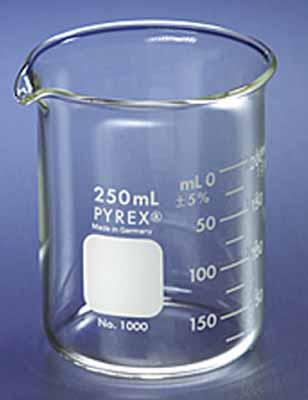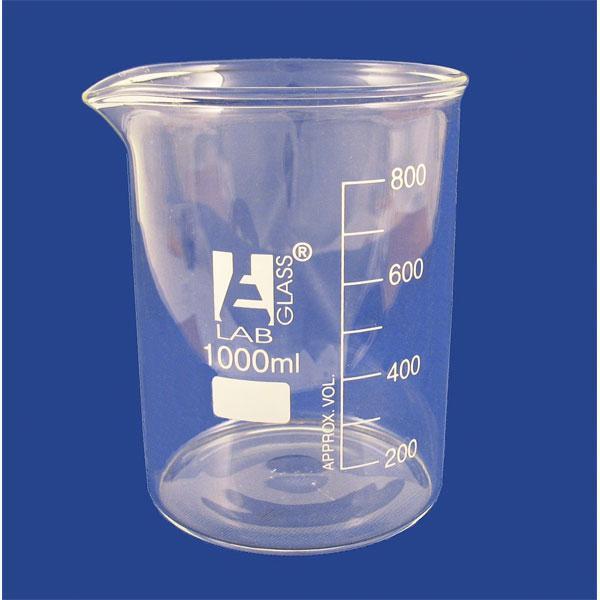The first image is the image on the left, the second image is the image on the right. For the images shown, is this caption "there is red liquid in a glass beaker" true? Answer yes or no. No. The first image is the image on the left, the second image is the image on the right. Analyze the images presented: Is the assertion "There is no less than one clear beaker with red liquid in it" valid? Answer yes or no. No. 